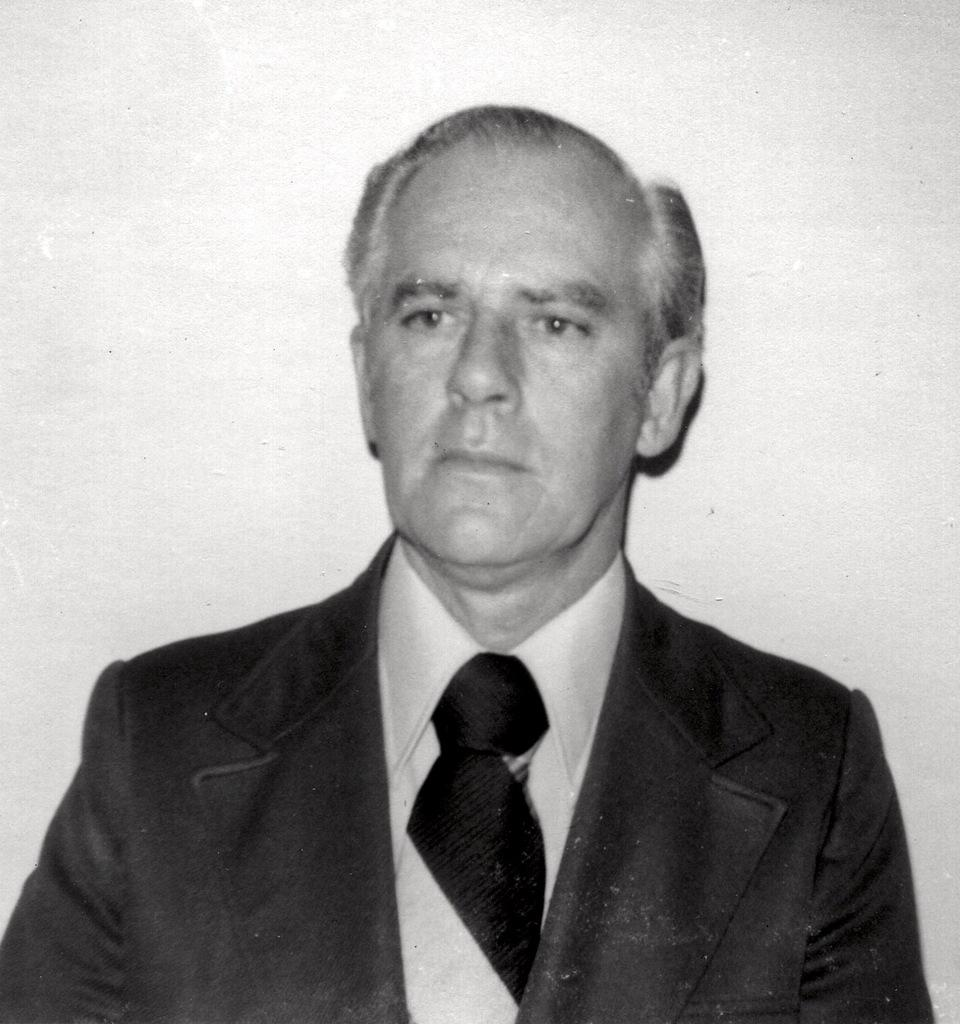What is the main subject of the image? There is a person in the image. What is the person wearing in the image? The person is wearing a suit, a tie, and a white color shirt. What can be seen in the background of the image? There is a white color wall in the background of the image. What type of belief can be seen in the person's facial expression in the image? There is no indication of a belief or any emotions in the person's facial expression in the image. What type of clouds can be seen in the image? There are no clouds visible in the image; it features a person in front of a white color wall. 